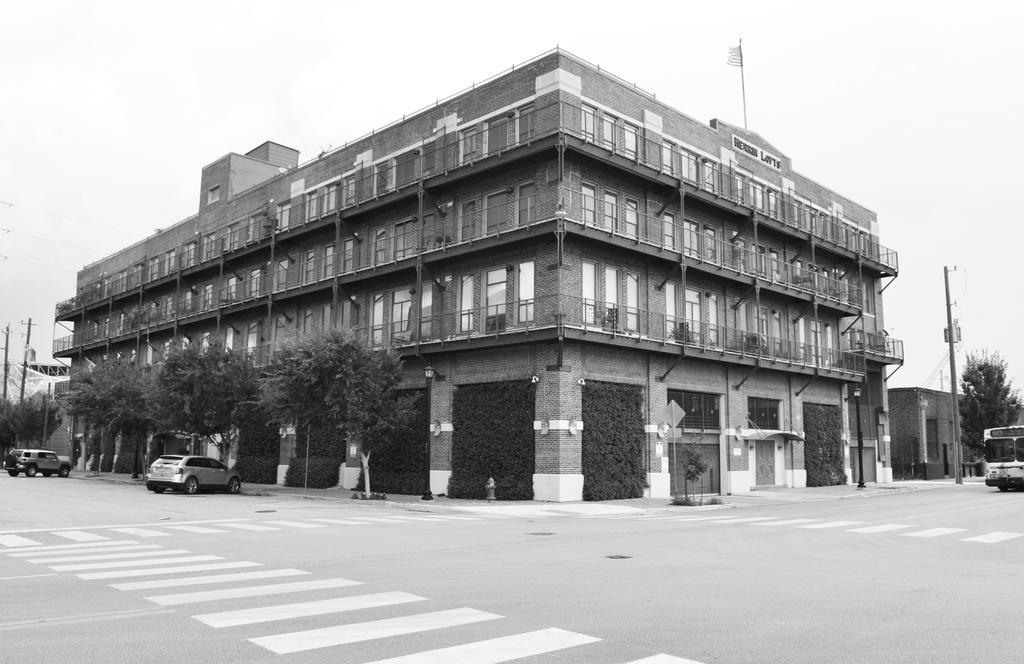In one or two sentences, can you explain what this image depicts? It is a black and white image. In the middle there is a building, on the left side there are trees. At the bottom two cars are parked, at the top it is the sky. 